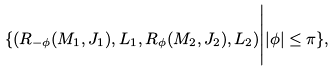Convert formula to latex. <formula><loc_0><loc_0><loc_500><loc_500>\{ ( R _ { - \phi } ( M _ { 1 } , J _ { 1 } ) , L _ { 1 } , R _ { \phi } ( M _ { 2 } , J _ { 2 } ) , L _ { 2 } ) \Big | | \phi | \leq \pi \} ,</formula> 